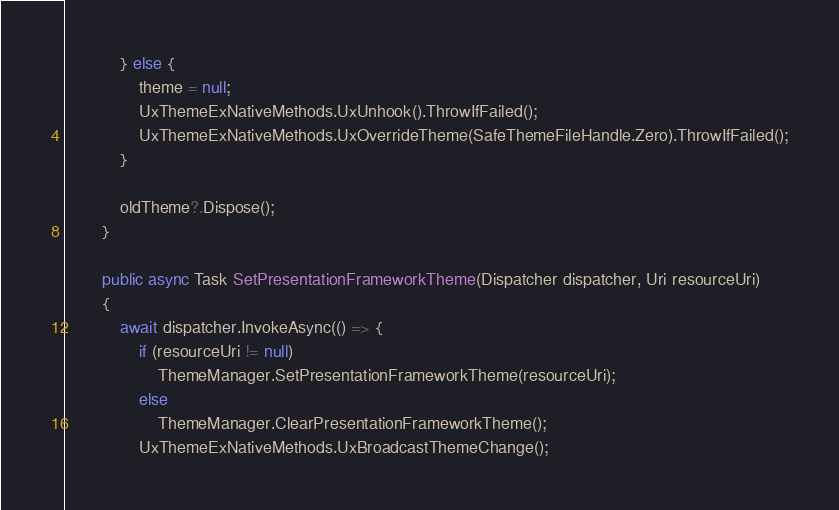<code> <loc_0><loc_0><loc_500><loc_500><_C#_>            } else {
                theme = null;
                UxThemeExNativeMethods.UxUnhook().ThrowIfFailed();
                UxThemeExNativeMethods.UxOverrideTheme(SafeThemeFileHandle.Zero).ThrowIfFailed();
            }

            oldTheme?.Dispose();
        }

        public async Task SetPresentationFrameworkTheme(Dispatcher dispatcher, Uri resourceUri)
        {
            await dispatcher.InvokeAsync(() => {
                if (resourceUri != null)
                    ThemeManager.SetPresentationFrameworkTheme(resourceUri);
                else
                    ThemeManager.ClearPresentationFrameworkTheme();
                UxThemeExNativeMethods.UxBroadcastThemeChange();</code> 